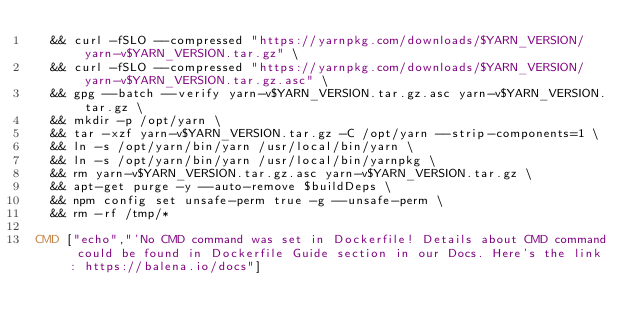<code> <loc_0><loc_0><loc_500><loc_500><_Dockerfile_>	&& curl -fSLO --compressed "https://yarnpkg.com/downloads/$YARN_VERSION/yarn-v$YARN_VERSION.tar.gz" \
	&& curl -fSLO --compressed "https://yarnpkg.com/downloads/$YARN_VERSION/yarn-v$YARN_VERSION.tar.gz.asc" \
	&& gpg --batch --verify yarn-v$YARN_VERSION.tar.gz.asc yarn-v$YARN_VERSION.tar.gz \
	&& mkdir -p /opt/yarn \
	&& tar -xzf yarn-v$YARN_VERSION.tar.gz -C /opt/yarn --strip-components=1 \
	&& ln -s /opt/yarn/bin/yarn /usr/local/bin/yarn \
	&& ln -s /opt/yarn/bin/yarn /usr/local/bin/yarnpkg \
	&& rm yarn-v$YARN_VERSION.tar.gz.asc yarn-v$YARN_VERSION.tar.gz \
	&& apt-get purge -y --auto-remove $buildDeps \
	&& npm config set unsafe-perm true -g --unsafe-perm \
	&& rm -rf /tmp/*

CMD ["echo","'No CMD command was set in Dockerfile! Details about CMD command could be found in Dockerfile Guide section in our Docs. Here's the link: https://balena.io/docs"]</code> 